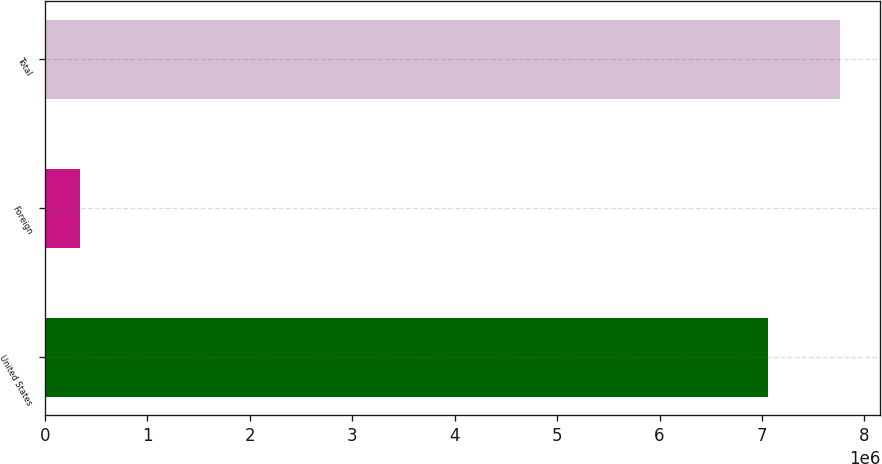<chart> <loc_0><loc_0><loc_500><loc_500><bar_chart><fcel>United States<fcel>Foreign<fcel>Total<nl><fcel>7.05882e+06<fcel>344639<fcel>7.76471e+06<nl></chart> 